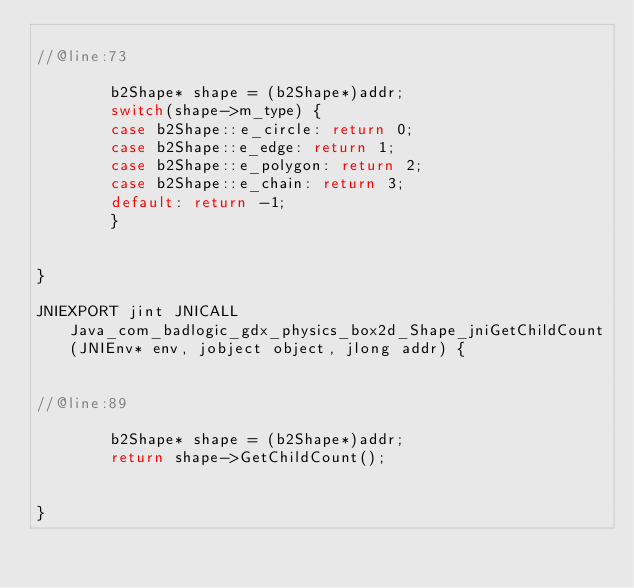Convert code to text. <code><loc_0><loc_0><loc_500><loc_500><_C++_>
//@line:73

		b2Shape* shape = (b2Shape*)addr;
		switch(shape->m_type) {
		case b2Shape::e_circle: return 0;
		case b2Shape::e_edge: return 1;
		case b2Shape::e_polygon: return 2;
		case b2Shape::e_chain: return 3;
		default: return -1;
		}
	

}

JNIEXPORT jint JNICALL Java_com_badlogic_gdx_physics_box2d_Shape_jniGetChildCount(JNIEnv* env, jobject object, jlong addr) {


//@line:89

		b2Shape* shape = (b2Shape*)addr;
		return shape->GetChildCount();
	

}

</code> 